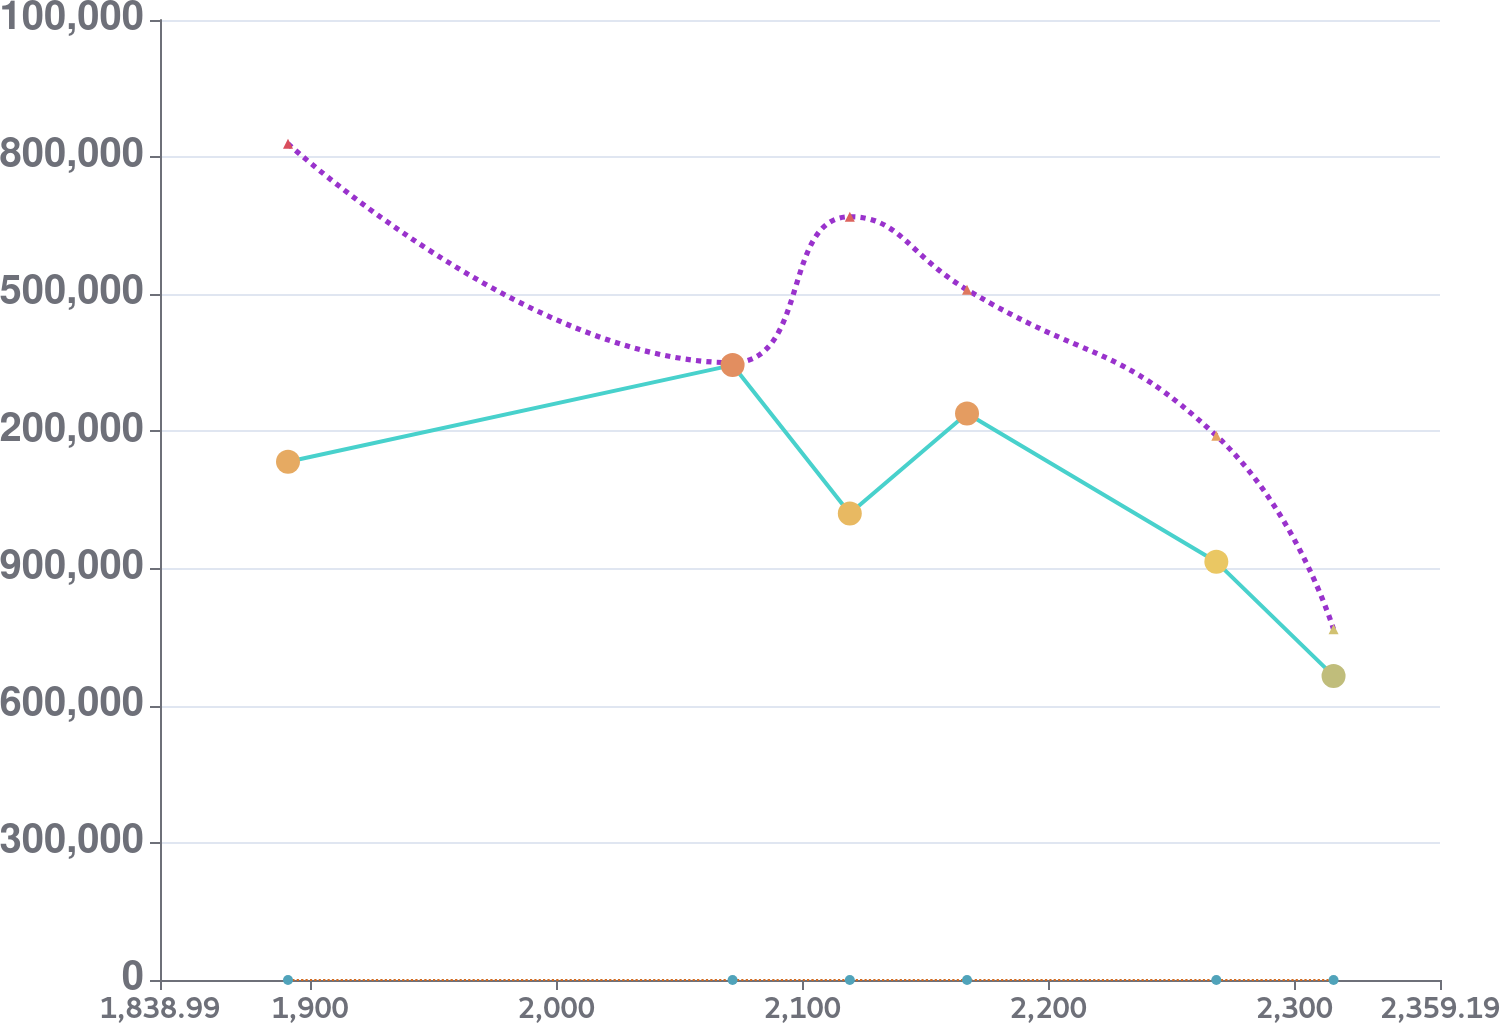Convert chart to OTSL. <chart><loc_0><loc_0><loc_500><loc_500><line_chart><ecel><fcel>Unnamed: 1<fcel>Con Edison of New York<fcel>Con Edison<nl><fcel>1891.01<fcel>8.2<fcel>1.82927e+06<fcel>1.13357e+06<nl><fcel>2071.69<fcel>9.46<fcel>1.35036e+06<fcel>1.3451e+06<nl><fcel>2119.33<fcel>7.43<fcel>1.66963e+06<fcel>1.0205e+06<nl><fcel>2166.97<fcel>6<fcel>1.51e+06<fcel>1.23934e+06<nl><fcel>2268.29<fcel>5.05<fcel>1.19073e+06<fcel>914734<nl><fcel>2315.93<fcel>3.69<fcel>767121<fcel>665215<nl><fcel>2363.57<fcel>2.77<fcel>209703<fcel>129560<nl><fcel>2411.21<fcel>1.78<fcel>926756<fcel>808965<nl></chart> 